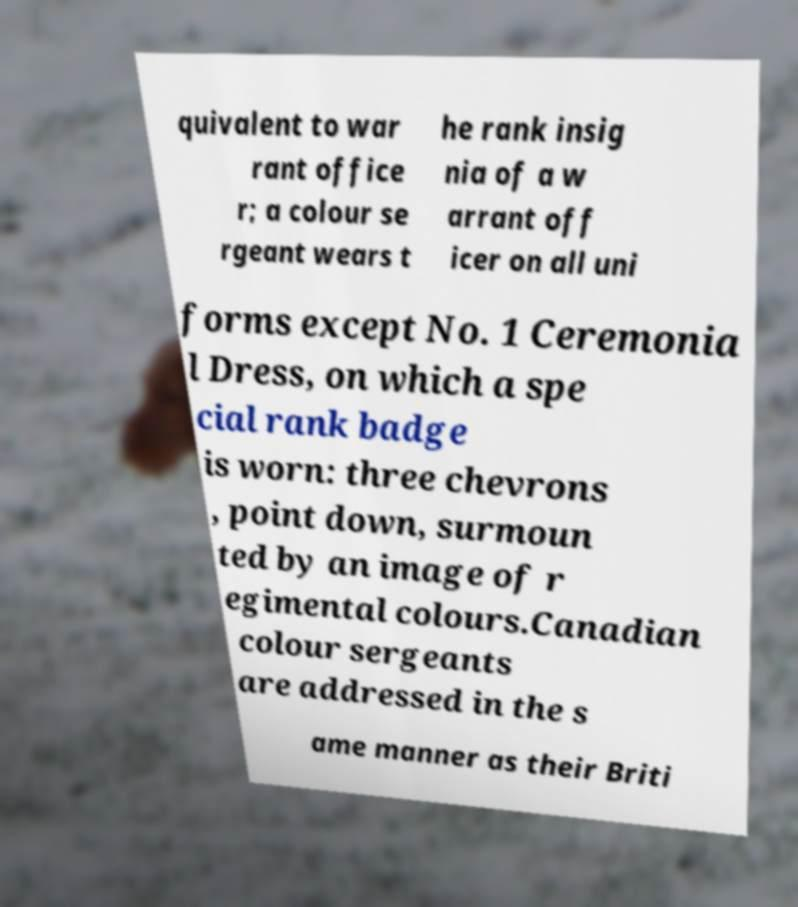Please identify and transcribe the text found in this image. quivalent to war rant office r; a colour se rgeant wears t he rank insig nia of a w arrant off icer on all uni forms except No. 1 Ceremonia l Dress, on which a spe cial rank badge is worn: three chevrons , point down, surmoun ted by an image of r egimental colours.Canadian colour sergeants are addressed in the s ame manner as their Briti 